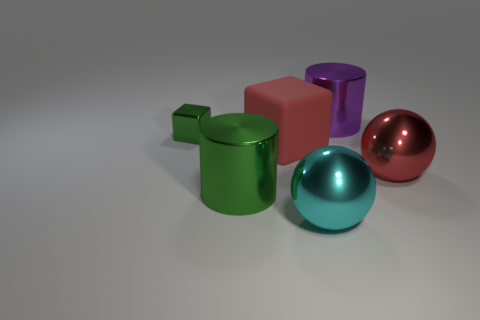Add 1 small green shiny cylinders. How many objects exist? 7 Subtract all cubes. How many objects are left? 4 Subtract all red metallic spheres. Subtract all brown matte objects. How many objects are left? 5 Add 3 large cyan spheres. How many large cyan spheres are left? 4 Add 6 big cyan metallic things. How many big cyan metallic things exist? 7 Subtract 0 blue blocks. How many objects are left? 6 